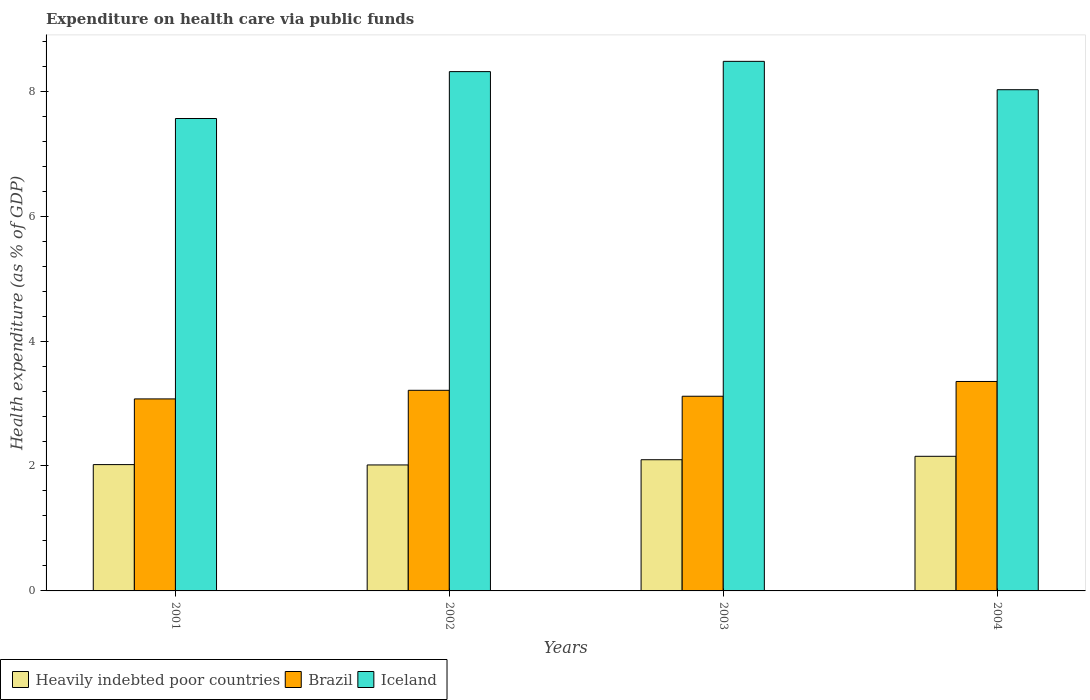Are the number of bars per tick equal to the number of legend labels?
Provide a succinct answer. Yes. Are the number of bars on each tick of the X-axis equal?
Your response must be concise. Yes. How many bars are there on the 3rd tick from the right?
Provide a short and direct response. 3. What is the label of the 3rd group of bars from the left?
Your answer should be compact. 2003. What is the expenditure made on health care in Heavily indebted poor countries in 2002?
Offer a terse response. 2.02. Across all years, what is the maximum expenditure made on health care in Heavily indebted poor countries?
Make the answer very short. 2.16. Across all years, what is the minimum expenditure made on health care in Heavily indebted poor countries?
Offer a very short reply. 2.02. In which year was the expenditure made on health care in Heavily indebted poor countries maximum?
Keep it short and to the point. 2004. In which year was the expenditure made on health care in Brazil minimum?
Your answer should be compact. 2001. What is the total expenditure made on health care in Heavily indebted poor countries in the graph?
Your answer should be compact. 8.29. What is the difference between the expenditure made on health care in Heavily indebted poor countries in 2002 and that in 2003?
Ensure brevity in your answer.  -0.08. What is the difference between the expenditure made on health care in Iceland in 2001 and the expenditure made on health care in Brazil in 2004?
Your response must be concise. 4.21. What is the average expenditure made on health care in Brazil per year?
Provide a succinct answer. 3.19. In the year 2004, what is the difference between the expenditure made on health care in Iceland and expenditure made on health care in Heavily indebted poor countries?
Your response must be concise. 5.87. What is the ratio of the expenditure made on health care in Iceland in 2002 to that in 2003?
Ensure brevity in your answer.  0.98. Is the expenditure made on health care in Iceland in 2001 less than that in 2002?
Ensure brevity in your answer.  Yes. Is the difference between the expenditure made on health care in Iceland in 2001 and 2004 greater than the difference between the expenditure made on health care in Heavily indebted poor countries in 2001 and 2004?
Provide a short and direct response. No. What is the difference between the highest and the second highest expenditure made on health care in Heavily indebted poor countries?
Offer a very short reply. 0.05. What is the difference between the highest and the lowest expenditure made on health care in Heavily indebted poor countries?
Offer a terse response. 0.14. Is the sum of the expenditure made on health care in Brazil in 2002 and 2004 greater than the maximum expenditure made on health care in Heavily indebted poor countries across all years?
Provide a succinct answer. Yes. How many bars are there?
Provide a short and direct response. 12. What is the difference between two consecutive major ticks on the Y-axis?
Provide a succinct answer. 2. Are the values on the major ticks of Y-axis written in scientific E-notation?
Offer a terse response. No. How many legend labels are there?
Provide a short and direct response. 3. How are the legend labels stacked?
Your answer should be very brief. Horizontal. What is the title of the graph?
Ensure brevity in your answer.  Expenditure on health care via public funds. Does "Tunisia" appear as one of the legend labels in the graph?
Provide a succinct answer. No. What is the label or title of the X-axis?
Your answer should be compact. Years. What is the label or title of the Y-axis?
Offer a terse response. Health expenditure (as % of GDP). What is the Health expenditure (as % of GDP) of Heavily indebted poor countries in 2001?
Offer a very short reply. 2.02. What is the Health expenditure (as % of GDP) in Brazil in 2001?
Give a very brief answer. 3.07. What is the Health expenditure (as % of GDP) in Iceland in 2001?
Your response must be concise. 7.56. What is the Health expenditure (as % of GDP) of Heavily indebted poor countries in 2002?
Give a very brief answer. 2.02. What is the Health expenditure (as % of GDP) of Brazil in 2002?
Give a very brief answer. 3.21. What is the Health expenditure (as % of GDP) in Iceland in 2002?
Offer a terse response. 8.31. What is the Health expenditure (as % of GDP) in Heavily indebted poor countries in 2003?
Provide a short and direct response. 2.1. What is the Health expenditure (as % of GDP) of Brazil in 2003?
Provide a succinct answer. 3.12. What is the Health expenditure (as % of GDP) of Iceland in 2003?
Make the answer very short. 8.48. What is the Health expenditure (as % of GDP) in Heavily indebted poor countries in 2004?
Your answer should be very brief. 2.16. What is the Health expenditure (as % of GDP) in Brazil in 2004?
Your answer should be compact. 3.35. What is the Health expenditure (as % of GDP) of Iceland in 2004?
Keep it short and to the point. 8.02. Across all years, what is the maximum Health expenditure (as % of GDP) in Heavily indebted poor countries?
Keep it short and to the point. 2.16. Across all years, what is the maximum Health expenditure (as % of GDP) of Brazil?
Your response must be concise. 3.35. Across all years, what is the maximum Health expenditure (as % of GDP) in Iceland?
Your answer should be compact. 8.48. Across all years, what is the minimum Health expenditure (as % of GDP) of Heavily indebted poor countries?
Make the answer very short. 2.02. Across all years, what is the minimum Health expenditure (as % of GDP) in Brazil?
Offer a terse response. 3.07. Across all years, what is the minimum Health expenditure (as % of GDP) of Iceland?
Offer a very short reply. 7.56. What is the total Health expenditure (as % of GDP) in Heavily indebted poor countries in the graph?
Your response must be concise. 8.29. What is the total Health expenditure (as % of GDP) in Brazil in the graph?
Provide a short and direct response. 12.76. What is the total Health expenditure (as % of GDP) of Iceland in the graph?
Provide a succinct answer. 32.38. What is the difference between the Health expenditure (as % of GDP) of Heavily indebted poor countries in 2001 and that in 2002?
Your answer should be very brief. 0.01. What is the difference between the Health expenditure (as % of GDP) in Brazil in 2001 and that in 2002?
Provide a succinct answer. -0.14. What is the difference between the Health expenditure (as % of GDP) in Iceland in 2001 and that in 2002?
Your response must be concise. -0.75. What is the difference between the Health expenditure (as % of GDP) in Heavily indebted poor countries in 2001 and that in 2003?
Your answer should be compact. -0.08. What is the difference between the Health expenditure (as % of GDP) of Brazil in 2001 and that in 2003?
Provide a short and direct response. -0.04. What is the difference between the Health expenditure (as % of GDP) of Iceland in 2001 and that in 2003?
Your answer should be very brief. -0.92. What is the difference between the Health expenditure (as % of GDP) of Heavily indebted poor countries in 2001 and that in 2004?
Provide a succinct answer. -0.13. What is the difference between the Health expenditure (as % of GDP) of Brazil in 2001 and that in 2004?
Your answer should be compact. -0.28. What is the difference between the Health expenditure (as % of GDP) of Iceland in 2001 and that in 2004?
Ensure brevity in your answer.  -0.46. What is the difference between the Health expenditure (as % of GDP) of Heavily indebted poor countries in 2002 and that in 2003?
Ensure brevity in your answer.  -0.08. What is the difference between the Health expenditure (as % of GDP) of Brazil in 2002 and that in 2003?
Your answer should be very brief. 0.1. What is the difference between the Health expenditure (as % of GDP) in Iceland in 2002 and that in 2003?
Provide a short and direct response. -0.16. What is the difference between the Health expenditure (as % of GDP) of Heavily indebted poor countries in 2002 and that in 2004?
Your response must be concise. -0.14. What is the difference between the Health expenditure (as % of GDP) of Brazil in 2002 and that in 2004?
Make the answer very short. -0.14. What is the difference between the Health expenditure (as % of GDP) in Iceland in 2002 and that in 2004?
Your answer should be very brief. 0.29. What is the difference between the Health expenditure (as % of GDP) of Heavily indebted poor countries in 2003 and that in 2004?
Provide a short and direct response. -0.05. What is the difference between the Health expenditure (as % of GDP) in Brazil in 2003 and that in 2004?
Your response must be concise. -0.24. What is the difference between the Health expenditure (as % of GDP) in Iceland in 2003 and that in 2004?
Offer a terse response. 0.45. What is the difference between the Health expenditure (as % of GDP) in Heavily indebted poor countries in 2001 and the Health expenditure (as % of GDP) in Brazil in 2002?
Offer a very short reply. -1.19. What is the difference between the Health expenditure (as % of GDP) of Heavily indebted poor countries in 2001 and the Health expenditure (as % of GDP) of Iceland in 2002?
Offer a terse response. -6.29. What is the difference between the Health expenditure (as % of GDP) in Brazil in 2001 and the Health expenditure (as % of GDP) in Iceland in 2002?
Give a very brief answer. -5.24. What is the difference between the Health expenditure (as % of GDP) of Heavily indebted poor countries in 2001 and the Health expenditure (as % of GDP) of Brazil in 2003?
Ensure brevity in your answer.  -1.09. What is the difference between the Health expenditure (as % of GDP) of Heavily indebted poor countries in 2001 and the Health expenditure (as % of GDP) of Iceland in 2003?
Your answer should be compact. -6.46. What is the difference between the Health expenditure (as % of GDP) in Brazil in 2001 and the Health expenditure (as % of GDP) in Iceland in 2003?
Keep it short and to the point. -5.4. What is the difference between the Health expenditure (as % of GDP) of Heavily indebted poor countries in 2001 and the Health expenditure (as % of GDP) of Brazil in 2004?
Provide a short and direct response. -1.33. What is the difference between the Health expenditure (as % of GDP) of Heavily indebted poor countries in 2001 and the Health expenditure (as % of GDP) of Iceland in 2004?
Offer a very short reply. -6. What is the difference between the Health expenditure (as % of GDP) in Brazil in 2001 and the Health expenditure (as % of GDP) in Iceland in 2004?
Offer a terse response. -4.95. What is the difference between the Health expenditure (as % of GDP) in Heavily indebted poor countries in 2002 and the Health expenditure (as % of GDP) in Iceland in 2003?
Make the answer very short. -6.46. What is the difference between the Health expenditure (as % of GDP) in Brazil in 2002 and the Health expenditure (as % of GDP) in Iceland in 2003?
Provide a succinct answer. -5.27. What is the difference between the Health expenditure (as % of GDP) of Heavily indebted poor countries in 2002 and the Health expenditure (as % of GDP) of Brazil in 2004?
Keep it short and to the point. -1.34. What is the difference between the Health expenditure (as % of GDP) of Heavily indebted poor countries in 2002 and the Health expenditure (as % of GDP) of Iceland in 2004?
Ensure brevity in your answer.  -6.01. What is the difference between the Health expenditure (as % of GDP) of Brazil in 2002 and the Health expenditure (as % of GDP) of Iceland in 2004?
Provide a succinct answer. -4.81. What is the difference between the Health expenditure (as % of GDP) in Heavily indebted poor countries in 2003 and the Health expenditure (as % of GDP) in Brazil in 2004?
Ensure brevity in your answer.  -1.25. What is the difference between the Health expenditure (as % of GDP) in Heavily indebted poor countries in 2003 and the Health expenditure (as % of GDP) in Iceland in 2004?
Offer a very short reply. -5.92. What is the difference between the Health expenditure (as % of GDP) of Brazil in 2003 and the Health expenditure (as % of GDP) of Iceland in 2004?
Give a very brief answer. -4.91. What is the average Health expenditure (as % of GDP) of Heavily indebted poor countries per year?
Give a very brief answer. 2.07. What is the average Health expenditure (as % of GDP) of Brazil per year?
Ensure brevity in your answer.  3.19. What is the average Health expenditure (as % of GDP) of Iceland per year?
Offer a terse response. 8.09. In the year 2001, what is the difference between the Health expenditure (as % of GDP) of Heavily indebted poor countries and Health expenditure (as % of GDP) of Brazil?
Keep it short and to the point. -1.05. In the year 2001, what is the difference between the Health expenditure (as % of GDP) of Heavily indebted poor countries and Health expenditure (as % of GDP) of Iceland?
Provide a succinct answer. -5.54. In the year 2001, what is the difference between the Health expenditure (as % of GDP) of Brazil and Health expenditure (as % of GDP) of Iceland?
Provide a short and direct response. -4.49. In the year 2002, what is the difference between the Health expenditure (as % of GDP) of Heavily indebted poor countries and Health expenditure (as % of GDP) of Brazil?
Your answer should be very brief. -1.2. In the year 2002, what is the difference between the Health expenditure (as % of GDP) in Heavily indebted poor countries and Health expenditure (as % of GDP) in Iceland?
Provide a short and direct response. -6.3. In the year 2002, what is the difference between the Health expenditure (as % of GDP) of Brazil and Health expenditure (as % of GDP) of Iceland?
Provide a short and direct response. -5.1. In the year 2003, what is the difference between the Health expenditure (as % of GDP) in Heavily indebted poor countries and Health expenditure (as % of GDP) in Brazil?
Offer a very short reply. -1.02. In the year 2003, what is the difference between the Health expenditure (as % of GDP) in Heavily indebted poor countries and Health expenditure (as % of GDP) in Iceland?
Provide a short and direct response. -6.38. In the year 2003, what is the difference between the Health expenditure (as % of GDP) of Brazil and Health expenditure (as % of GDP) of Iceland?
Your response must be concise. -5.36. In the year 2004, what is the difference between the Health expenditure (as % of GDP) of Heavily indebted poor countries and Health expenditure (as % of GDP) of Brazil?
Make the answer very short. -1.2. In the year 2004, what is the difference between the Health expenditure (as % of GDP) in Heavily indebted poor countries and Health expenditure (as % of GDP) in Iceland?
Offer a very short reply. -5.87. In the year 2004, what is the difference between the Health expenditure (as % of GDP) in Brazil and Health expenditure (as % of GDP) in Iceland?
Provide a short and direct response. -4.67. What is the ratio of the Health expenditure (as % of GDP) in Heavily indebted poor countries in 2001 to that in 2002?
Offer a very short reply. 1. What is the ratio of the Health expenditure (as % of GDP) of Brazil in 2001 to that in 2002?
Give a very brief answer. 0.96. What is the ratio of the Health expenditure (as % of GDP) in Iceland in 2001 to that in 2002?
Your response must be concise. 0.91. What is the ratio of the Health expenditure (as % of GDP) of Heavily indebted poor countries in 2001 to that in 2003?
Keep it short and to the point. 0.96. What is the ratio of the Health expenditure (as % of GDP) of Brazil in 2001 to that in 2003?
Your answer should be compact. 0.99. What is the ratio of the Health expenditure (as % of GDP) in Iceland in 2001 to that in 2003?
Ensure brevity in your answer.  0.89. What is the ratio of the Health expenditure (as % of GDP) in Heavily indebted poor countries in 2001 to that in 2004?
Provide a succinct answer. 0.94. What is the ratio of the Health expenditure (as % of GDP) in Brazil in 2001 to that in 2004?
Your answer should be very brief. 0.92. What is the ratio of the Health expenditure (as % of GDP) of Iceland in 2001 to that in 2004?
Give a very brief answer. 0.94. What is the ratio of the Health expenditure (as % of GDP) of Heavily indebted poor countries in 2002 to that in 2003?
Your answer should be compact. 0.96. What is the ratio of the Health expenditure (as % of GDP) in Brazil in 2002 to that in 2003?
Make the answer very short. 1.03. What is the ratio of the Health expenditure (as % of GDP) in Iceland in 2002 to that in 2003?
Provide a succinct answer. 0.98. What is the ratio of the Health expenditure (as % of GDP) of Heavily indebted poor countries in 2002 to that in 2004?
Ensure brevity in your answer.  0.94. What is the ratio of the Health expenditure (as % of GDP) in Brazil in 2002 to that in 2004?
Make the answer very short. 0.96. What is the ratio of the Health expenditure (as % of GDP) of Iceland in 2002 to that in 2004?
Provide a short and direct response. 1.04. What is the ratio of the Health expenditure (as % of GDP) of Heavily indebted poor countries in 2003 to that in 2004?
Your answer should be very brief. 0.97. What is the ratio of the Health expenditure (as % of GDP) in Brazil in 2003 to that in 2004?
Keep it short and to the point. 0.93. What is the ratio of the Health expenditure (as % of GDP) in Iceland in 2003 to that in 2004?
Offer a very short reply. 1.06. What is the difference between the highest and the second highest Health expenditure (as % of GDP) of Heavily indebted poor countries?
Provide a short and direct response. 0.05. What is the difference between the highest and the second highest Health expenditure (as % of GDP) of Brazil?
Provide a succinct answer. 0.14. What is the difference between the highest and the second highest Health expenditure (as % of GDP) in Iceland?
Keep it short and to the point. 0.16. What is the difference between the highest and the lowest Health expenditure (as % of GDP) of Heavily indebted poor countries?
Ensure brevity in your answer.  0.14. What is the difference between the highest and the lowest Health expenditure (as % of GDP) in Brazil?
Offer a very short reply. 0.28. What is the difference between the highest and the lowest Health expenditure (as % of GDP) of Iceland?
Your answer should be compact. 0.92. 